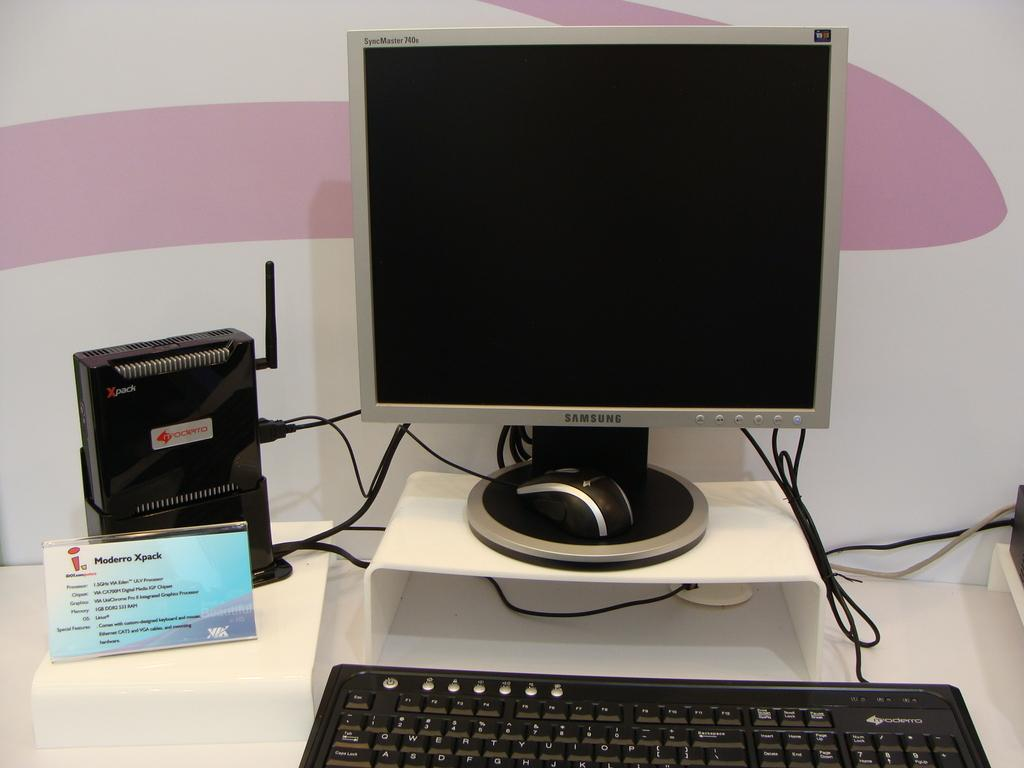<image>
Summarize the visual content of the image. A computer set up with a modem, a sign that says Moderro xpack 